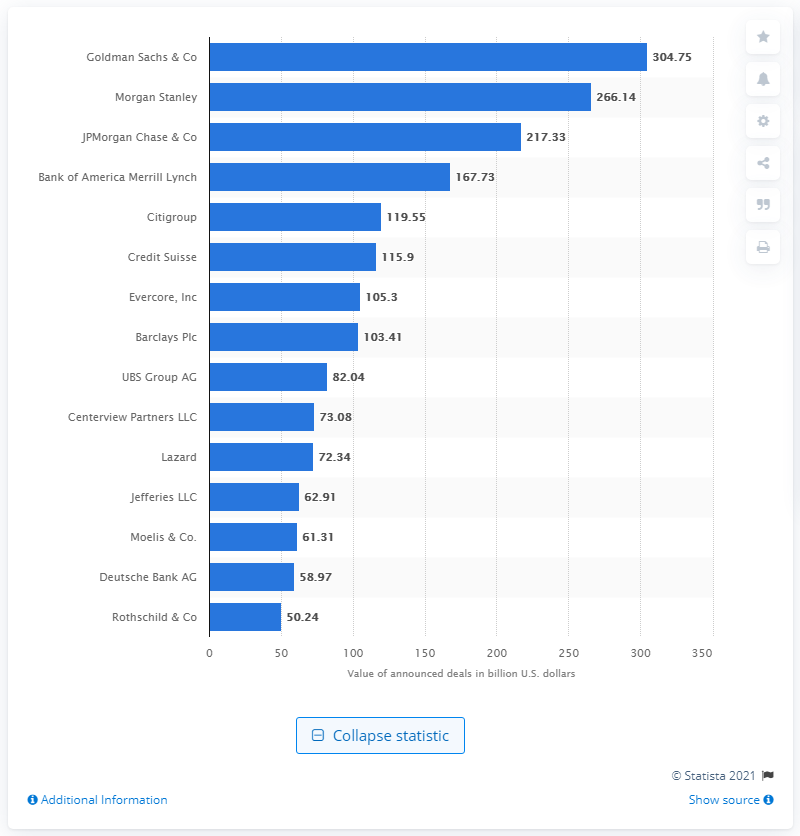Indicate a few pertinent items in this graphic. In 2020, Goldman Sachs & Co announced a total of 304.75 M&A deals. 